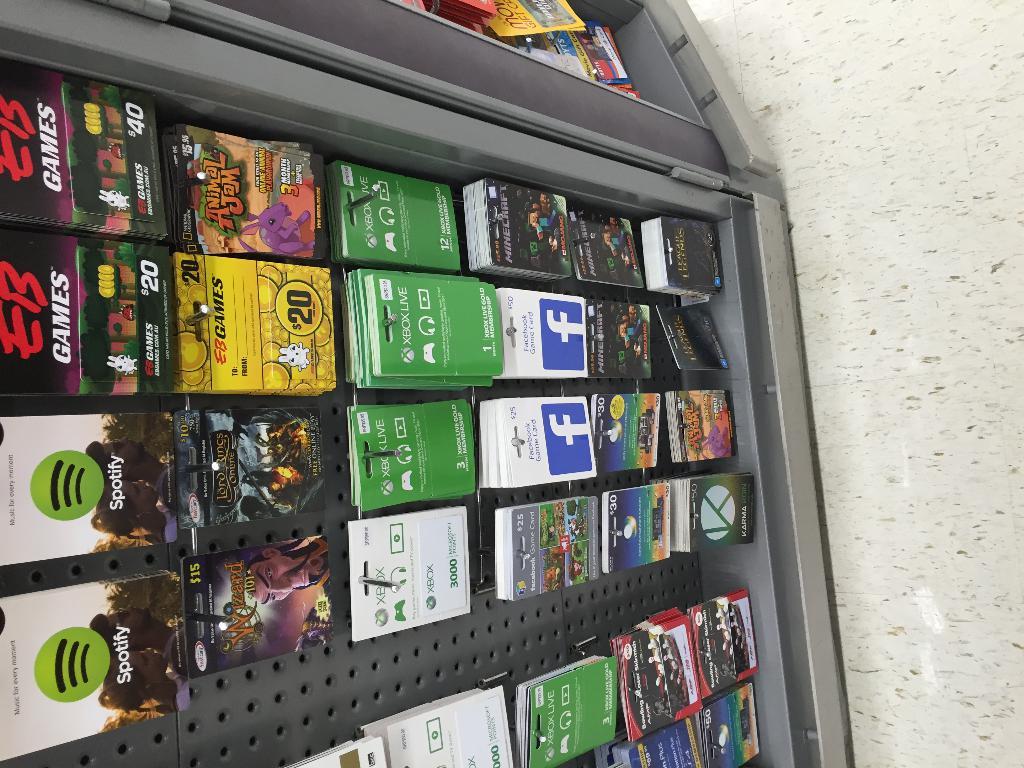What music service has a gift card at the top of this rack?
Offer a terse response. Spotify. What are the solid green gift cards for?
Your answer should be very brief. Xbox live. 